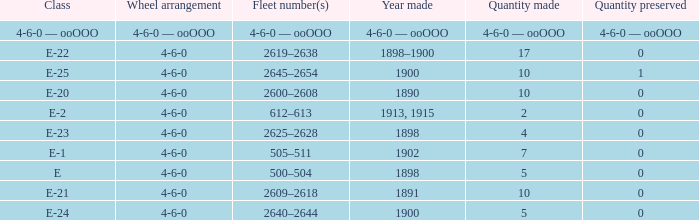What is the quantity preserved of the e-1 class? 0.0. 